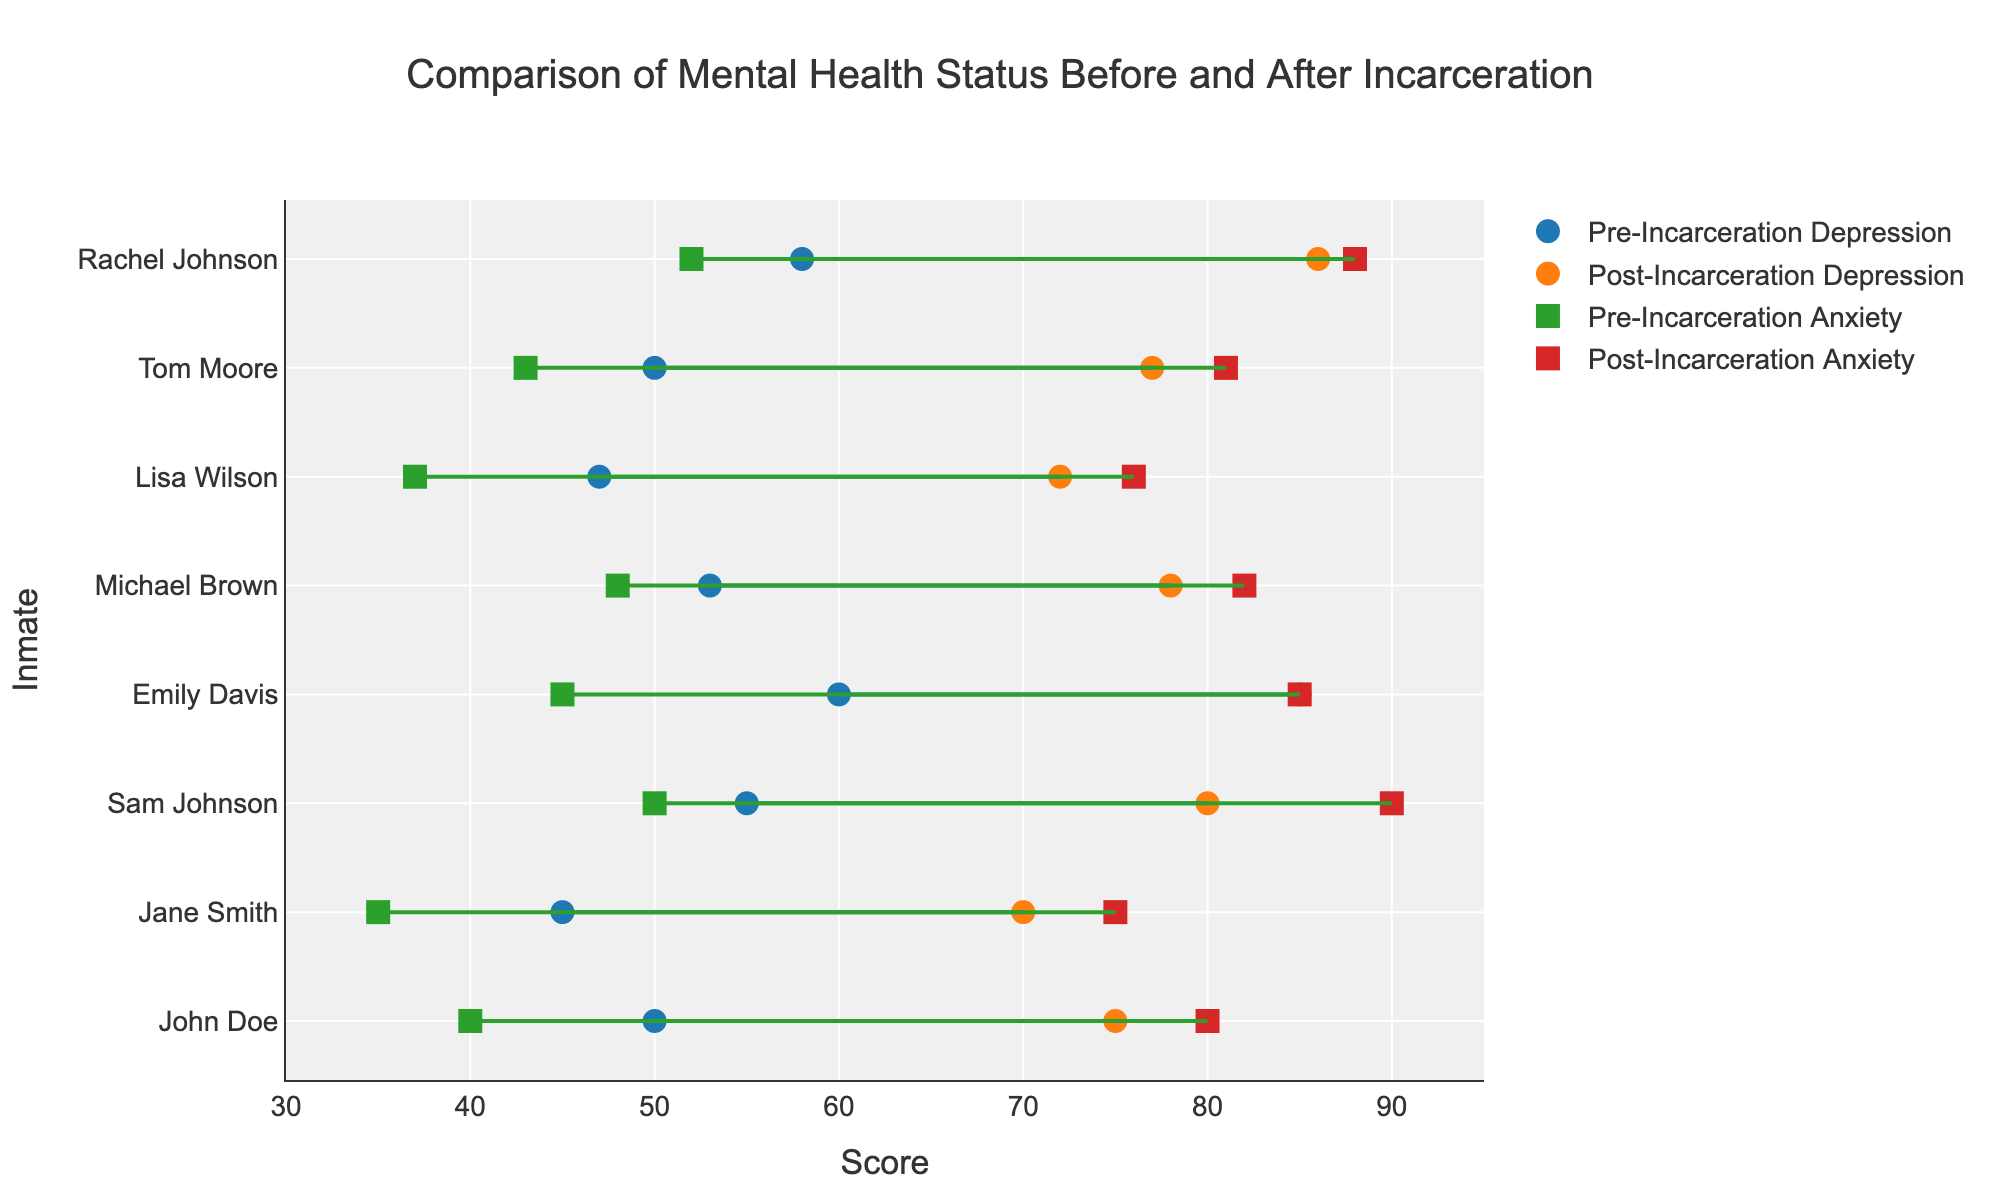What is the title of the plot? The title of the plot is found at the top of the figure. It provides an overarching summary of what the plot is about.
Answer: Comparison of Mental Health Status Before and After Incarceration How many inmates are represented in the plot? To find the number of inmates, count the number of unique names listed along the y-axis of the plot.
Answer: 8 Which inmate showed the highest increase in depression score after incarceration? To determine this, calculate the difference between the post-incarceration and pre-incarceration depression scores for each inmate, and identify the one with the largest gap. Rachel Johnson's scores increased from 58 to 86, which is the highest change of 28 points.
Answer: Rachel Johnson What are the two scores represented for each inmate in the plot? Examine the markers and lines in the plot: circles represent depression scores, squares represent anxiety scores. Each individual is linked by lines showing the progression from pre-incarceration to post-incarceration scores.
Answer: Depression and Anxiety scores Which inmate has the smallest difference in post-incarceration and pre-incarceration anxiety scores? Subtract the pre-incarceration anxiety score from the post-incarceration anxiety score for each inmate. The smallest difference is Lisa Wilson’s, with a change from 37 to 76, a difference of 39 points.
Answer: Lisa Wilson How did Tom Moore's depression score change after incarceration? Look at the markers for Tom Moore along the x-axis and compare the pre-incarceration and post-incarceration depression scores. The scores go from 50 to 77.
Answer: Increased by 27 points Which inmate had the highest post-incarceration anxiety score? Identify the highest value among the post-incarceration anxiety scores. The post-incarceration anxiety score for Sam Johnson is 90, the highest among the inmates.
Answer: Sam Johnson What color represents the pre-incarceration depression scores? Refer to the legend in the plot to find the color associated with pre-incarceration depression scores.
Answer: Blue How does the average pre-incarceration anxiety score compare to the average post-incarceration anxiety score? Compute the average of the pre-incarceration and post-incarceration anxiety scores: (40+35+50+45+48+37+43+52)/8 = 43.75 and (80+75+90+85+82+76+81+88)/8 = 82.125. The post-incarceration score average is higher.
Answer: Post-incarceration anxiety score average is higher Which inmate has the highest pre-incarceration depression score and what is their score? Look for the highest value in the pre-incarceration depression scores list. Emily Davis has the highest score with 60.
Answer: Emily Davis with a score of 60 